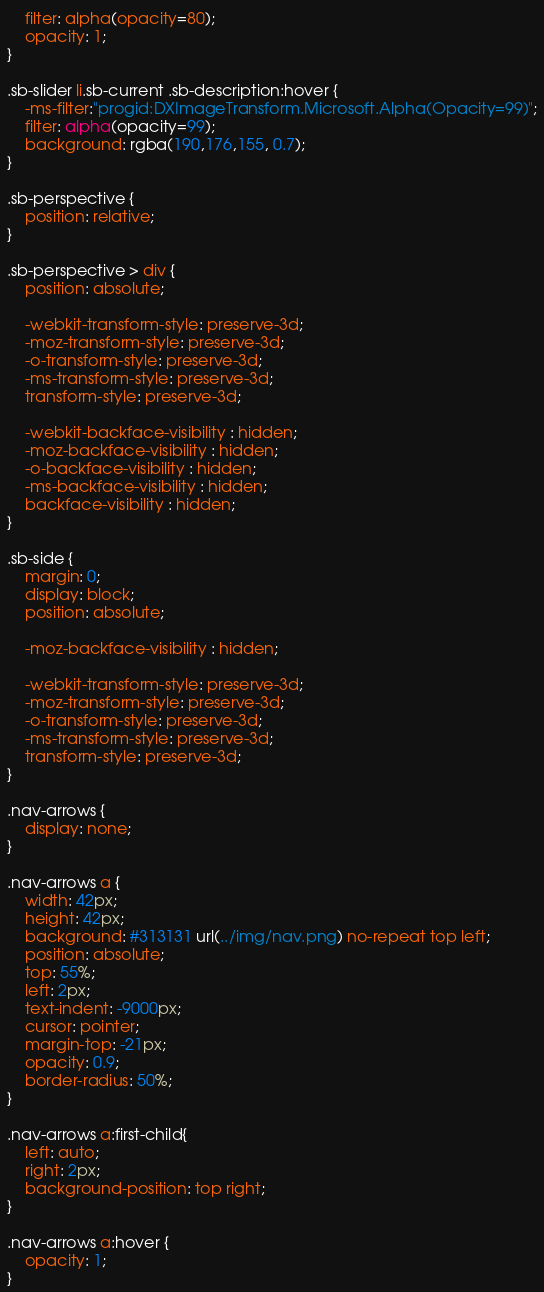Convert code to text. <code><loc_0><loc_0><loc_500><loc_500><_CSS_>	filter: alpha(opacity=80);	
	opacity: 1;
}

.sb-slider li.sb-current .sb-description:hover {
	-ms-filter:"progid:DXImageTransform.Microsoft.Alpha(Opacity=99)";
	filter: alpha(opacity=99);	
	background: rgba(190,176,155, 0.7);
}

.sb-perspective {
	position: relative;
}

.sb-perspective > div {
	position: absolute;

	-webkit-transform-style: preserve-3d;
	-moz-transform-style: preserve-3d;
	-o-transform-style: preserve-3d;
	-ms-transform-style: preserve-3d;
	transform-style: preserve-3d;

	-webkit-backface-visibility : hidden;
	-moz-backface-visibility : hidden;
	-o-backface-visibility : hidden;
	-ms-backface-visibility : hidden;
	backface-visibility : hidden;
}

.sb-side {
	margin: 0;
	display: block;
	position: absolute;

	-moz-backface-visibility : hidden;

	-webkit-transform-style: preserve-3d;
	-moz-transform-style: preserve-3d;
	-o-transform-style: preserve-3d;
	-ms-transform-style: preserve-3d;
	transform-style: preserve-3d;
}

.nav-arrows {
	display: none;
}

.nav-arrows a {
	width: 42px;
	height: 42px;
	background: #313131 url(../img/nav.png) no-repeat top left;
	position: absolute;
	top: 55%;
	left: 2px;
	text-indent: -9000px;
	cursor: pointer;
	margin-top: -21px;
	opacity: 0.9;
	border-radius: 50%;
}

.nav-arrows a:first-child{
	left: auto;
	right: 2px;
	background-position: top right;
}

.nav-arrows a:hover {
	opacity: 1;
}
</code> 